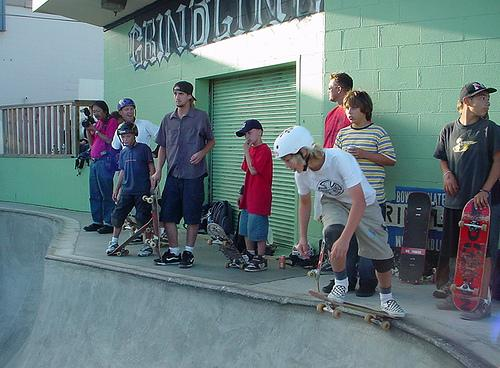What type of skate maneuver is the boy in white about to perform? jump 